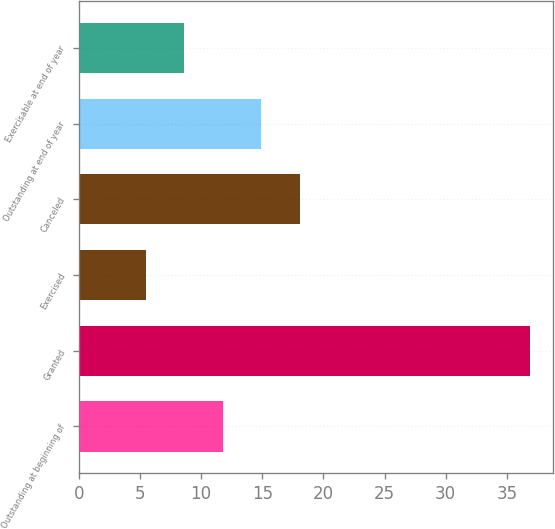Convert chart. <chart><loc_0><loc_0><loc_500><loc_500><bar_chart><fcel>Outstanding at beginning of<fcel>Granted<fcel>Exercised<fcel>Canceled<fcel>Outstanding at end of year<fcel>Exercisable at end of year<nl><fcel>11.76<fcel>36.92<fcel>5.46<fcel>18.06<fcel>14.91<fcel>8.61<nl></chart> 